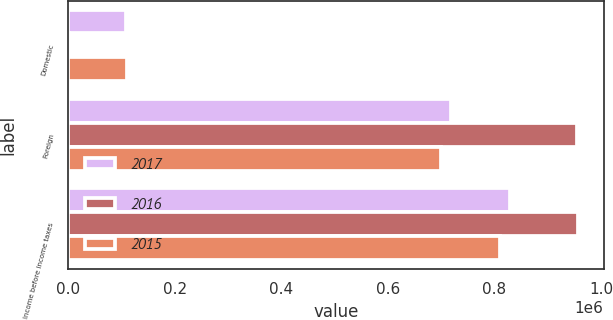Convert chart to OTSL. <chart><loc_0><loc_0><loc_500><loc_500><stacked_bar_chart><ecel><fcel>Domestic<fcel>Foreign<fcel>Income before income taxes<nl><fcel>2017<fcel>109565<fcel>718920<fcel>828485<nl><fcel>2016<fcel>2642<fcel>954279<fcel>956921<nl><fcel>2015<fcel>110710<fcel>699404<fcel>810114<nl></chart> 